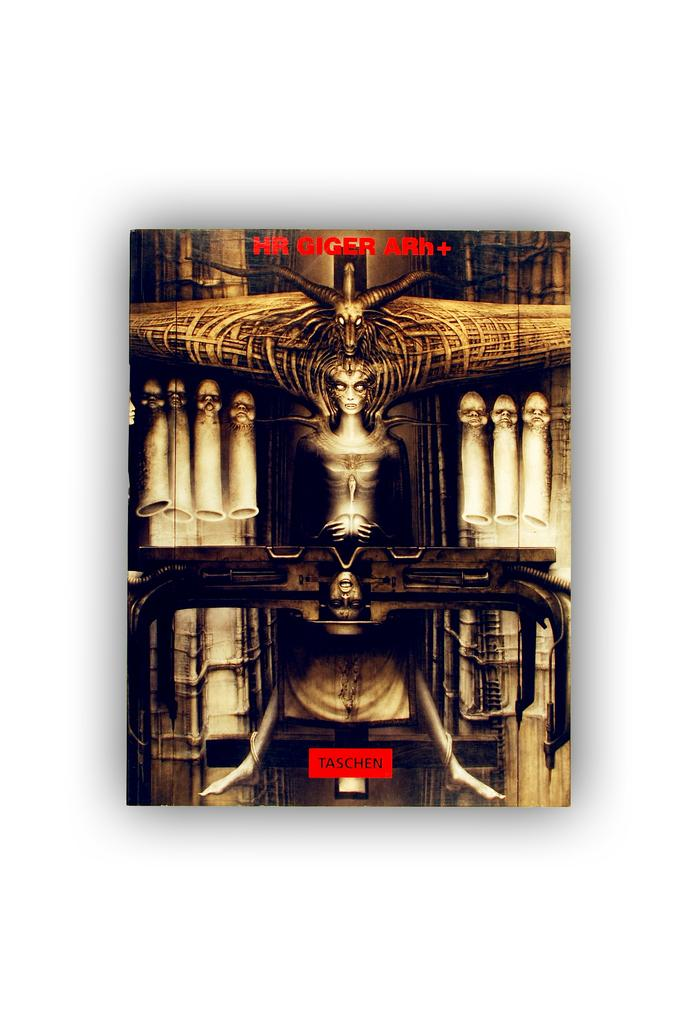<image>
Provide a brief description of the given image. a catalog by HR Giger Rh+ has a square in red that says Taschen. 